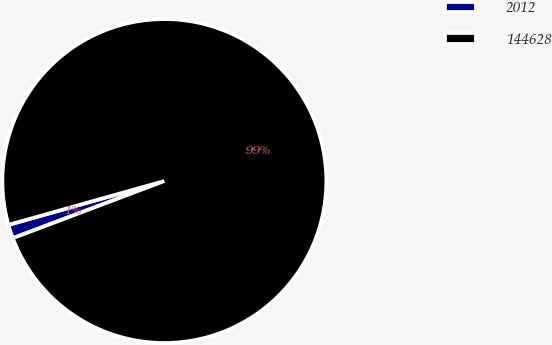Convert chart. <chart><loc_0><loc_0><loc_500><loc_500><pie_chart><fcel>2012<fcel>144628<nl><fcel>1.38%<fcel>98.62%<nl></chart> 